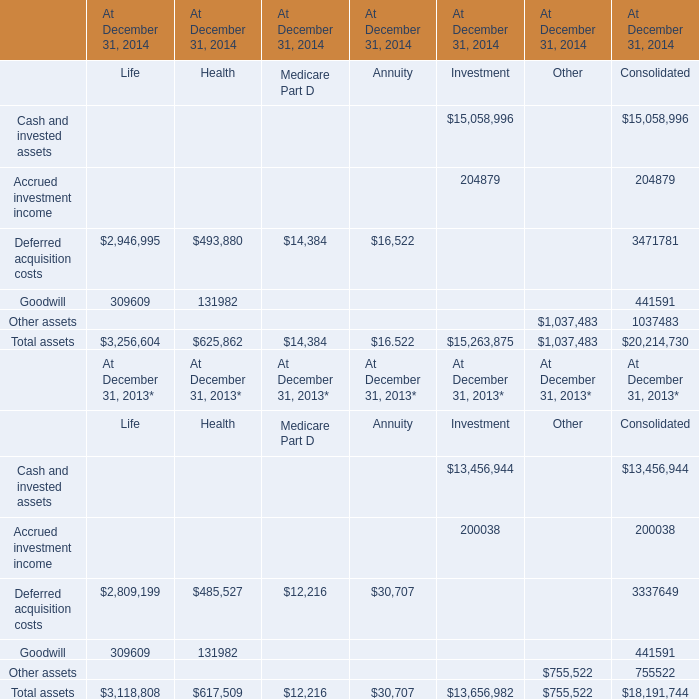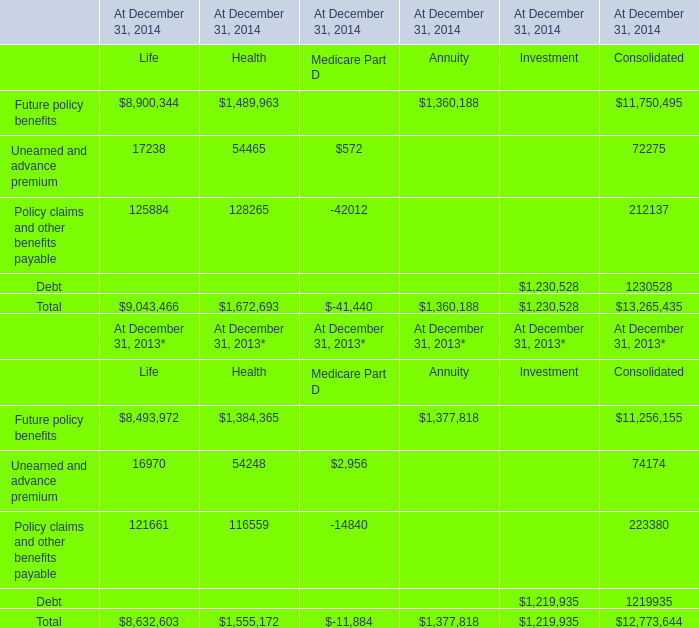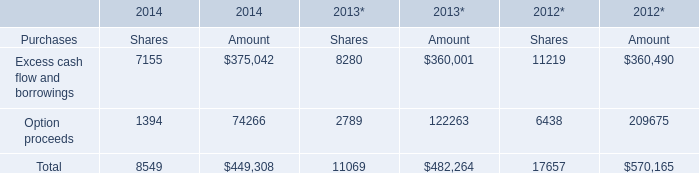What is the sum of the Other assets in the years where Accrued investment income greater than 0? 
Computations: (1037483 + 755522)
Answer: 1793005.0. 